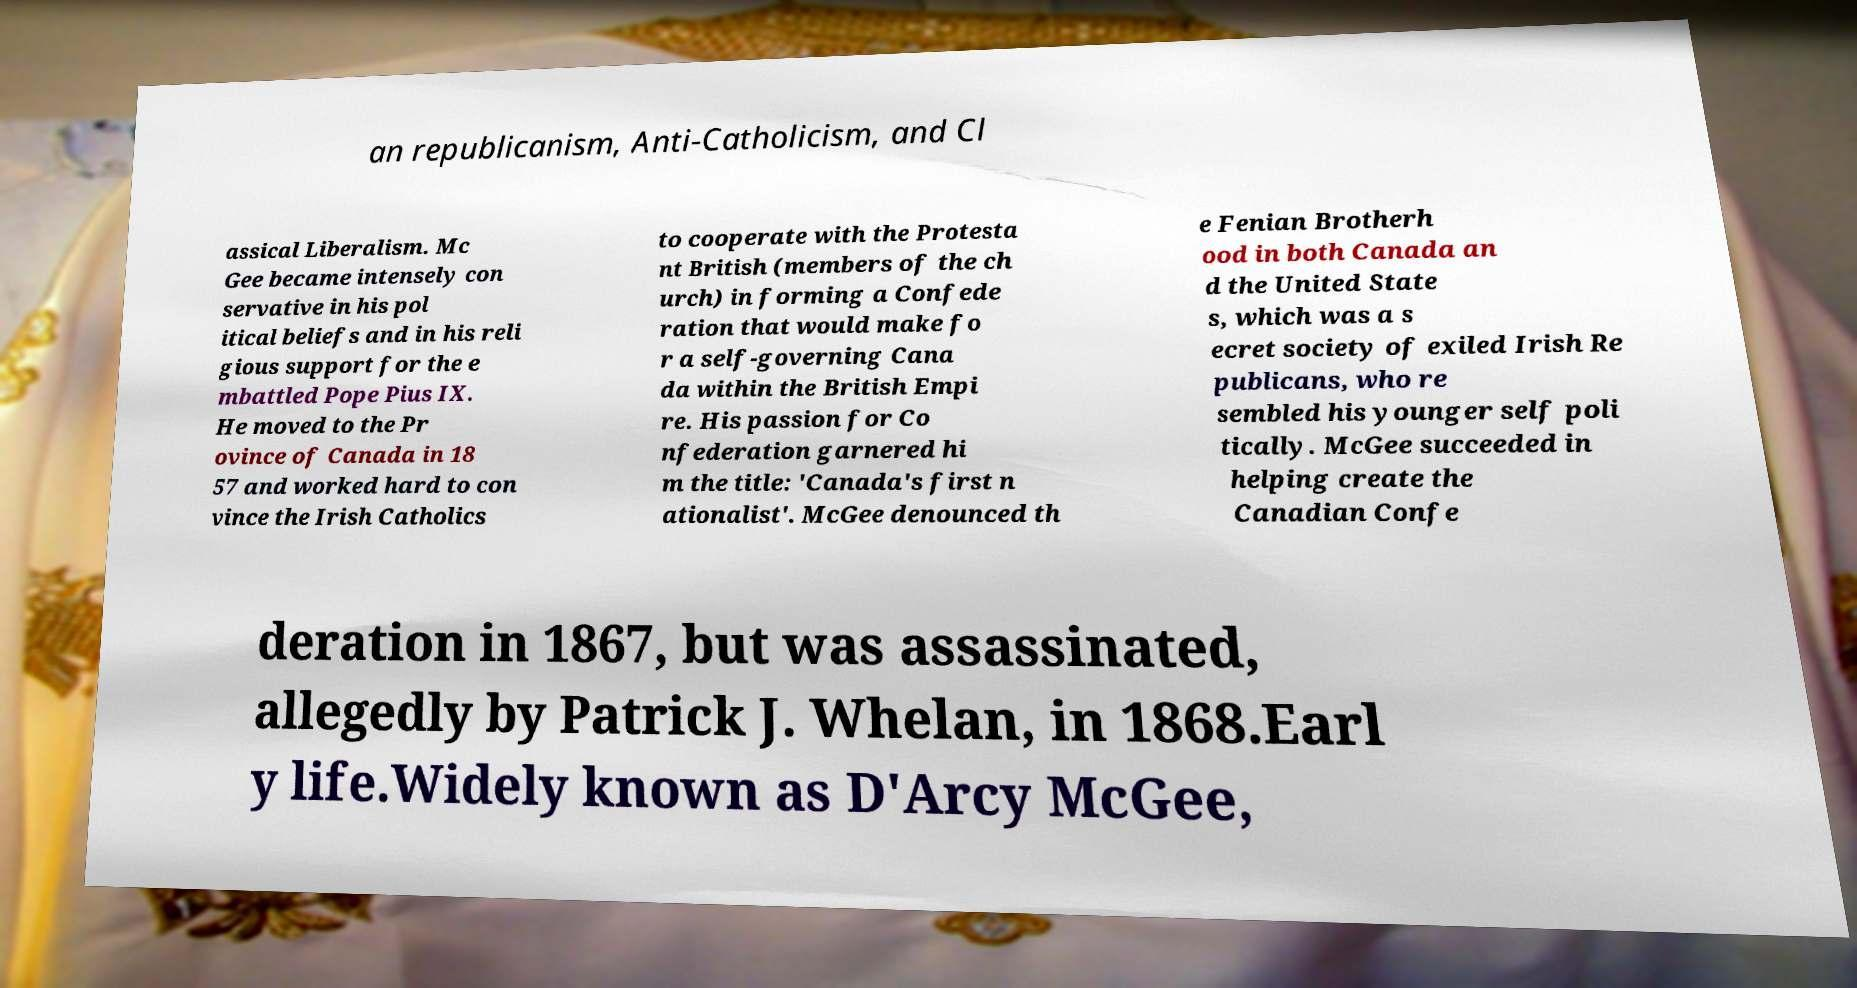There's text embedded in this image that I need extracted. Can you transcribe it verbatim? an republicanism, Anti-Catholicism, and Cl assical Liberalism. Mc Gee became intensely con servative in his pol itical beliefs and in his reli gious support for the e mbattled Pope Pius IX. He moved to the Pr ovince of Canada in 18 57 and worked hard to con vince the Irish Catholics to cooperate with the Protesta nt British (members of the ch urch) in forming a Confede ration that would make fo r a self-governing Cana da within the British Empi re. His passion for Co nfederation garnered hi m the title: 'Canada's first n ationalist'. McGee denounced th e Fenian Brotherh ood in both Canada an d the United State s, which was a s ecret society of exiled Irish Re publicans, who re sembled his younger self poli tically. McGee succeeded in helping create the Canadian Confe deration in 1867, but was assassinated, allegedly by Patrick J. Whelan, in 1868.Earl y life.Widely known as D'Arcy McGee, 